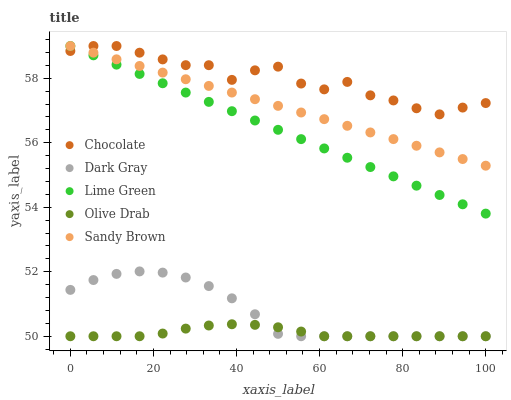Does Olive Drab have the minimum area under the curve?
Answer yes or no. Yes. Does Chocolate have the maximum area under the curve?
Answer yes or no. Yes. Does Sandy Brown have the minimum area under the curve?
Answer yes or no. No. Does Sandy Brown have the maximum area under the curve?
Answer yes or no. No. Is Sandy Brown the smoothest?
Answer yes or no. Yes. Is Chocolate the roughest?
Answer yes or no. Yes. Is Lime Green the smoothest?
Answer yes or no. No. Is Lime Green the roughest?
Answer yes or no. No. Does Dark Gray have the lowest value?
Answer yes or no. Yes. Does Sandy Brown have the lowest value?
Answer yes or no. No. Does Chocolate have the highest value?
Answer yes or no. Yes. Does Olive Drab have the highest value?
Answer yes or no. No. Is Olive Drab less than Lime Green?
Answer yes or no. Yes. Is Sandy Brown greater than Olive Drab?
Answer yes or no. Yes. Does Chocolate intersect Sandy Brown?
Answer yes or no. Yes. Is Chocolate less than Sandy Brown?
Answer yes or no. No. Is Chocolate greater than Sandy Brown?
Answer yes or no. No. Does Olive Drab intersect Lime Green?
Answer yes or no. No. 